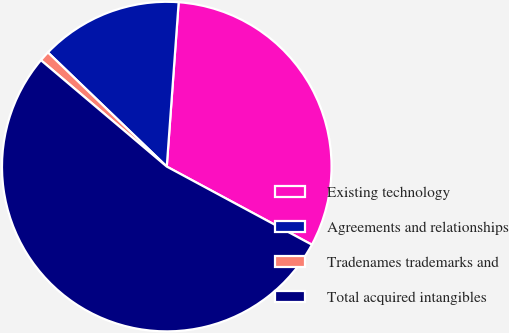Convert chart to OTSL. <chart><loc_0><loc_0><loc_500><loc_500><pie_chart><fcel>Existing technology<fcel>Agreements and relationships<fcel>Tradenames trademarks and<fcel>Total acquired intangibles<nl><fcel>31.71%<fcel>13.97%<fcel>1.01%<fcel>53.31%<nl></chart> 